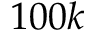Convert formula to latex. <formula><loc_0><loc_0><loc_500><loc_500>1 0 0 k</formula> 